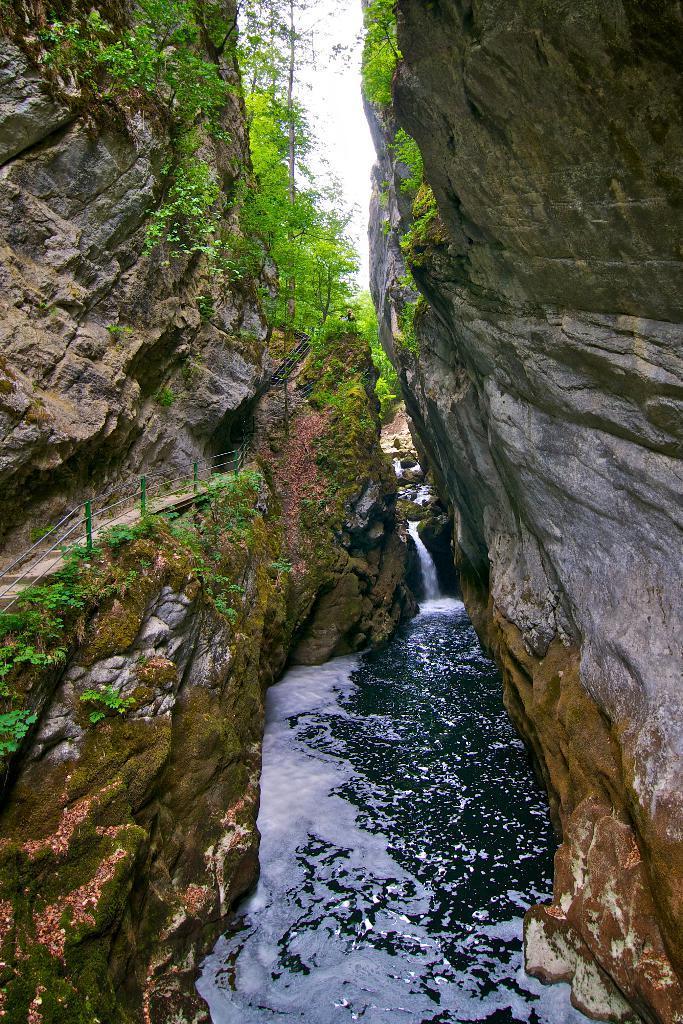Can you describe this image briefly? In the foreground of this image, there is a river flowing in between two cliffs and we can also see railing and path on a cliff. In the background, there are trees and the sky. 